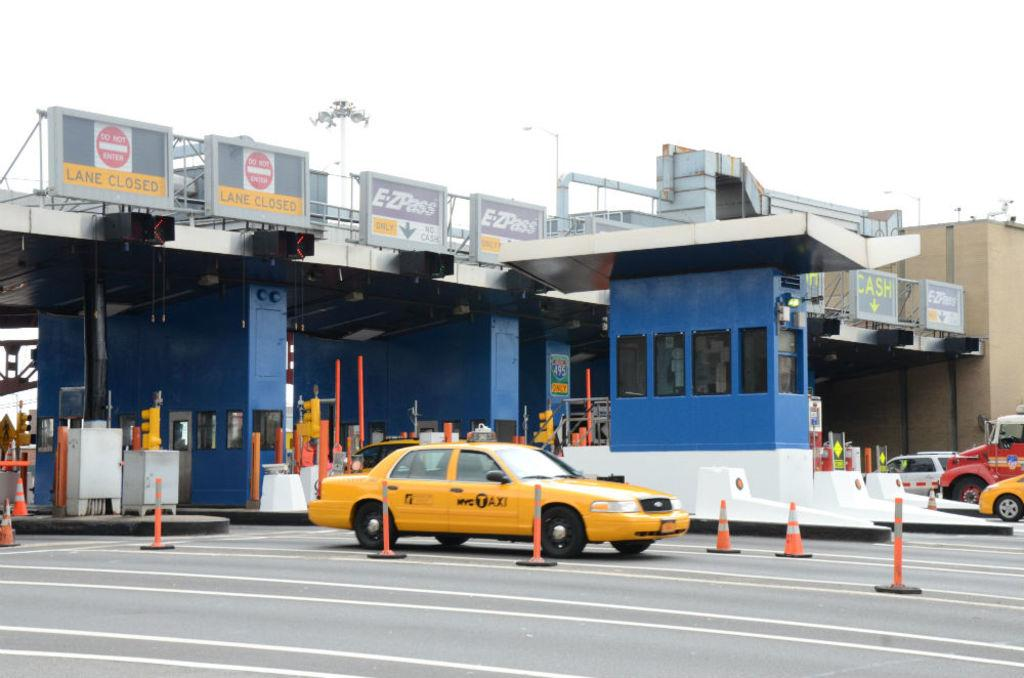Provide a one-sentence caption for the provided image. A yellow cab from the company NYC Taxi. 